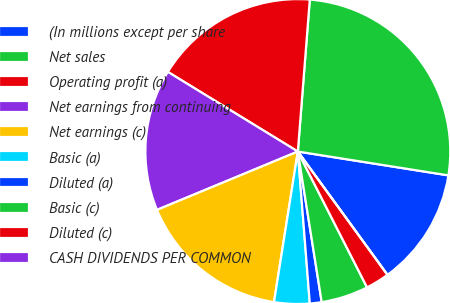<chart> <loc_0><loc_0><loc_500><loc_500><pie_chart><fcel>(In millions except per share<fcel>Net sales<fcel>Operating profit (a)<fcel>Net earnings from continuing<fcel>Net earnings (c)<fcel>Basic (a)<fcel>Diluted (a)<fcel>Basic (c)<fcel>Diluted (c)<fcel>CASH DIVIDENDS PER COMMON<nl><fcel>12.5%<fcel>26.25%<fcel>17.5%<fcel>15.0%<fcel>16.25%<fcel>3.75%<fcel>1.25%<fcel>5.0%<fcel>2.5%<fcel>0.0%<nl></chart> 